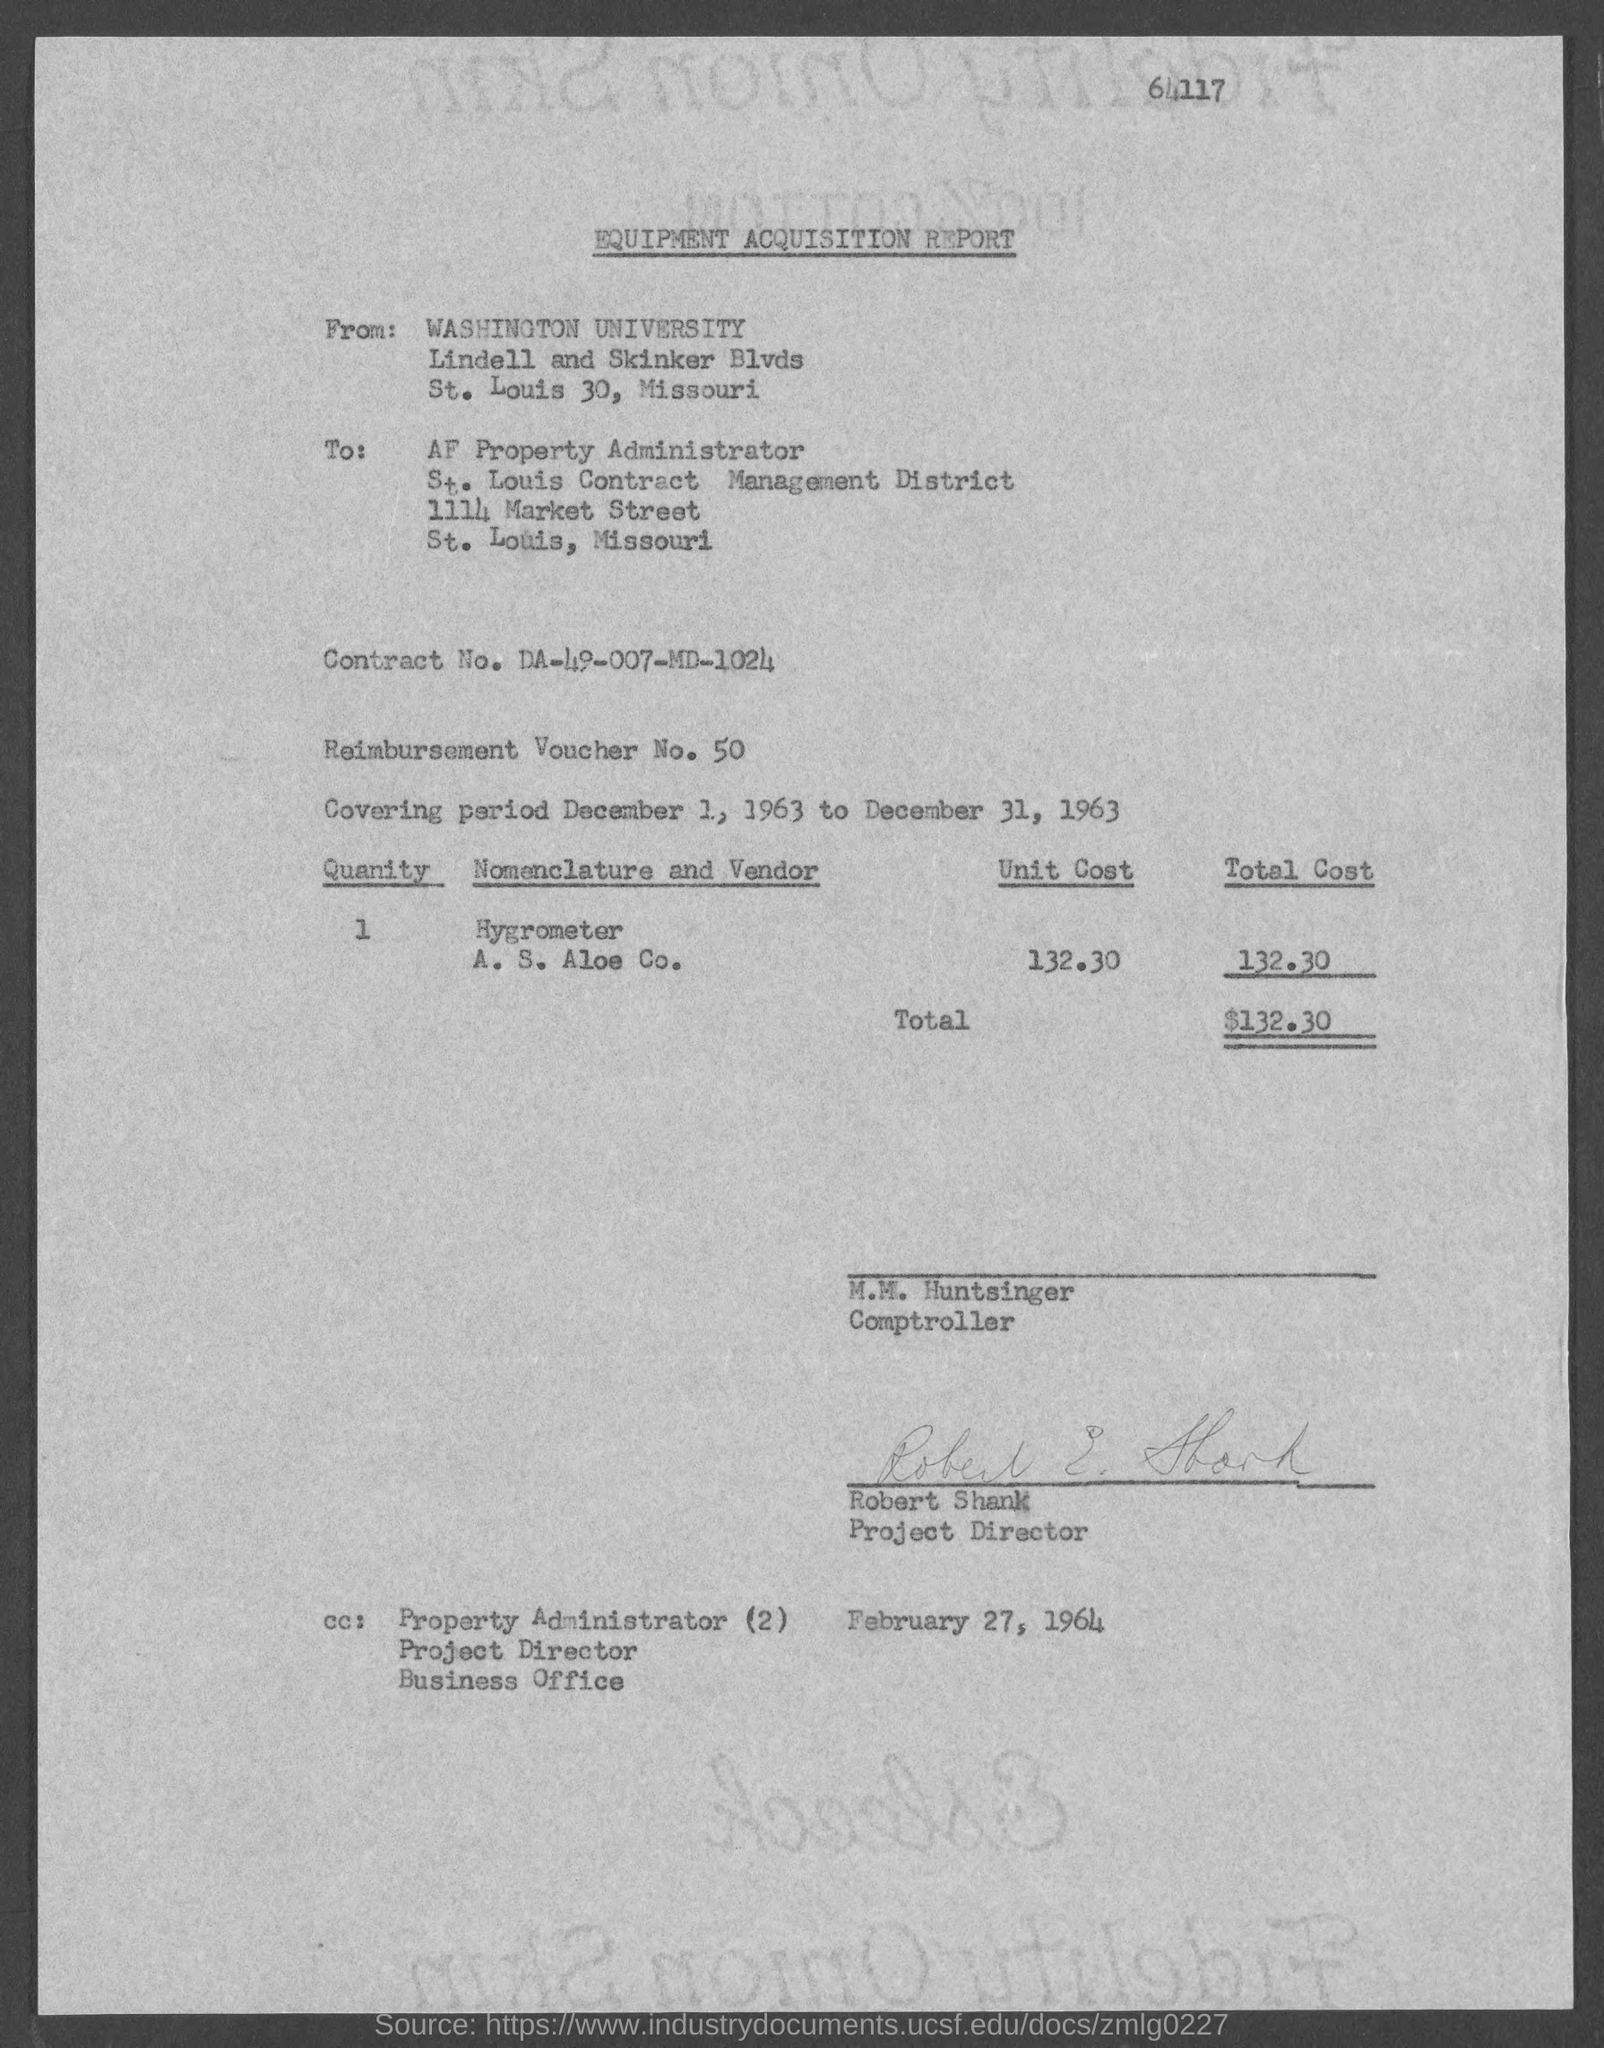Give some essential details in this illustration. The street address of Washington University is located at Lindell and Skinker Blvds. The Equipment Acquisition Report is the name of the report. The Reimbursement Voucher No. is 50. The total cost is $132.30. The street address of the AF Property Administrator is 1114 Market Street. 